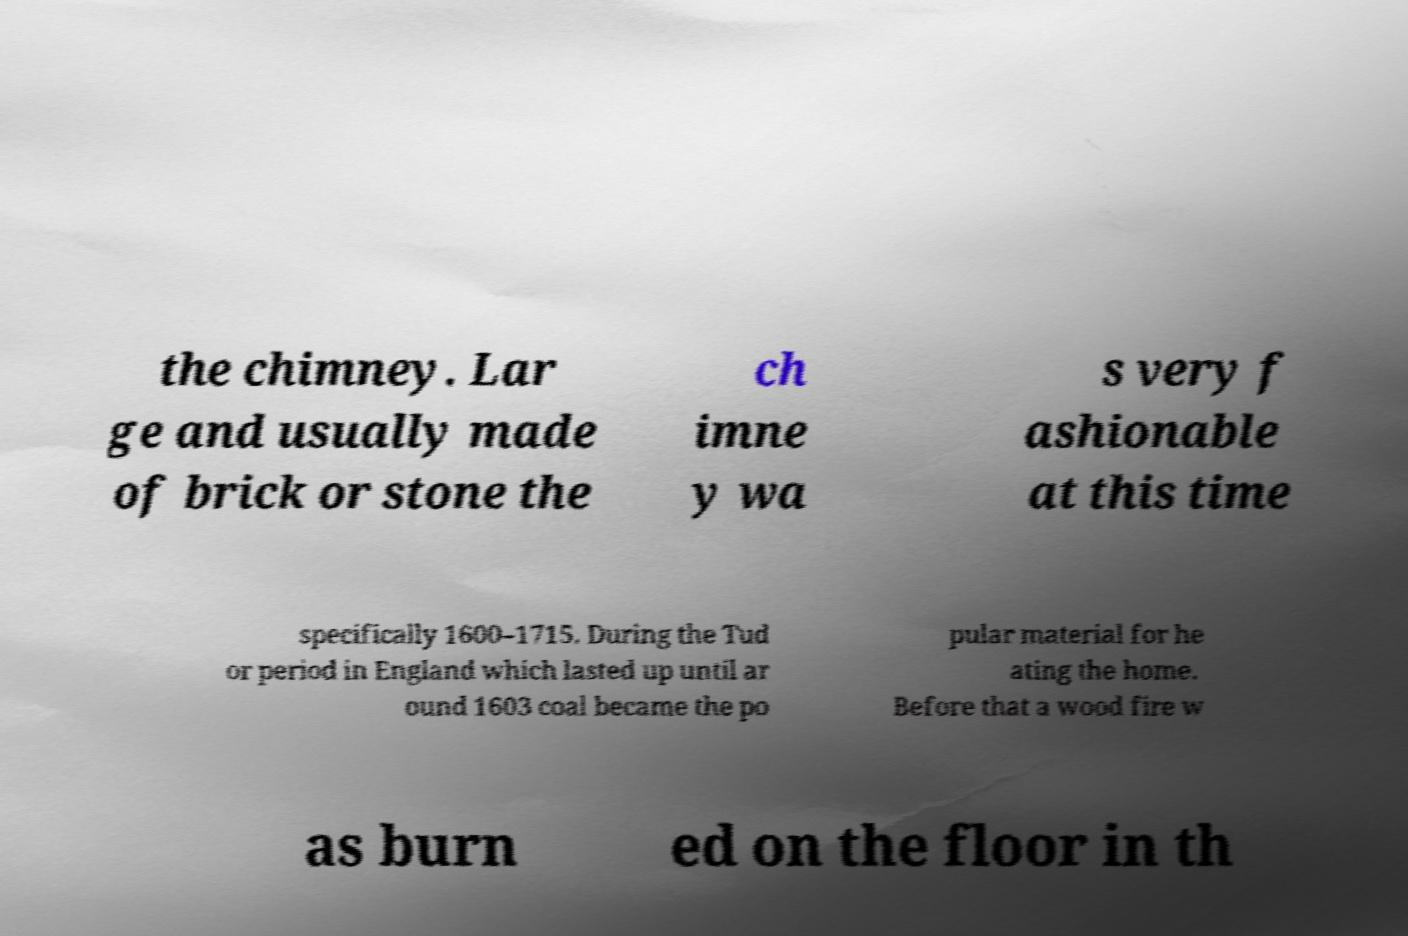Can you read and provide the text displayed in the image?This photo seems to have some interesting text. Can you extract and type it out for me? the chimney. Lar ge and usually made of brick or stone the ch imne y wa s very f ashionable at this time specifically 1600–1715. During the Tud or period in England which lasted up until ar ound 1603 coal became the po pular material for he ating the home. Before that a wood fire w as burn ed on the floor in th 